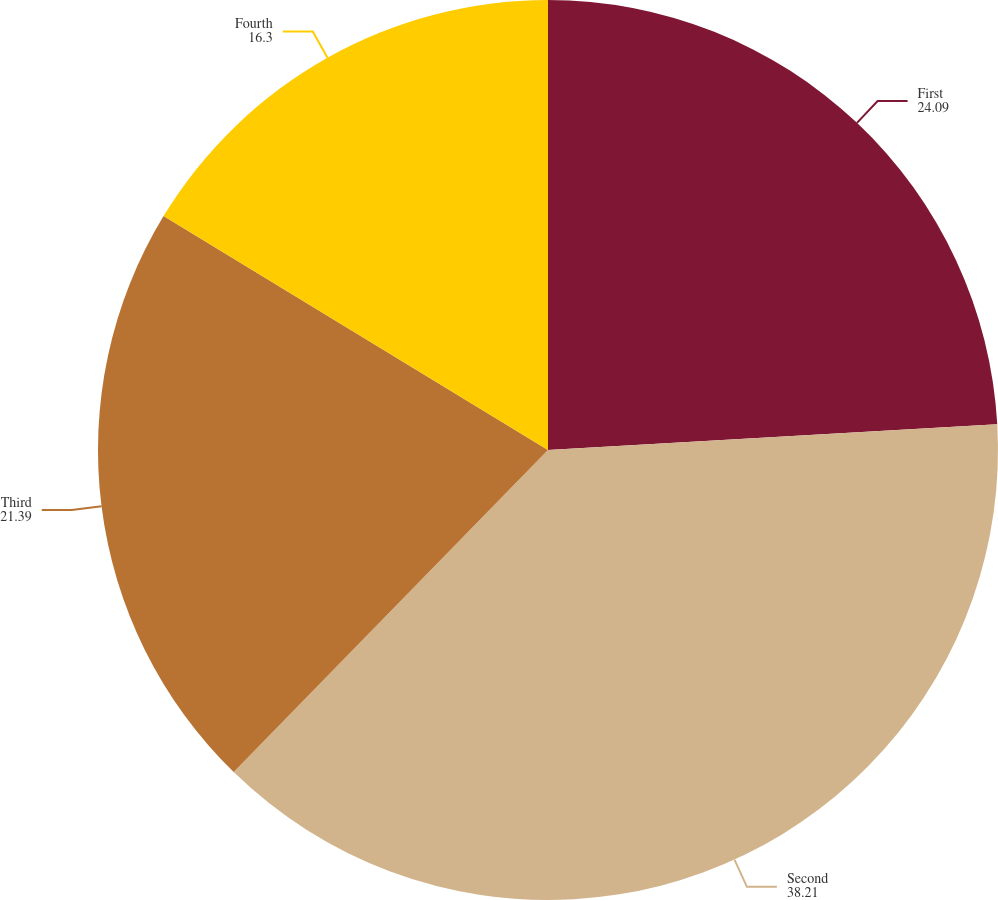<chart> <loc_0><loc_0><loc_500><loc_500><pie_chart><fcel>First<fcel>Second<fcel>Third<fcel>Fourth<nl><fcel>24.09%<fcel>38.21%<fcel>21.39%<fcel>16.3%<nl></chart> 